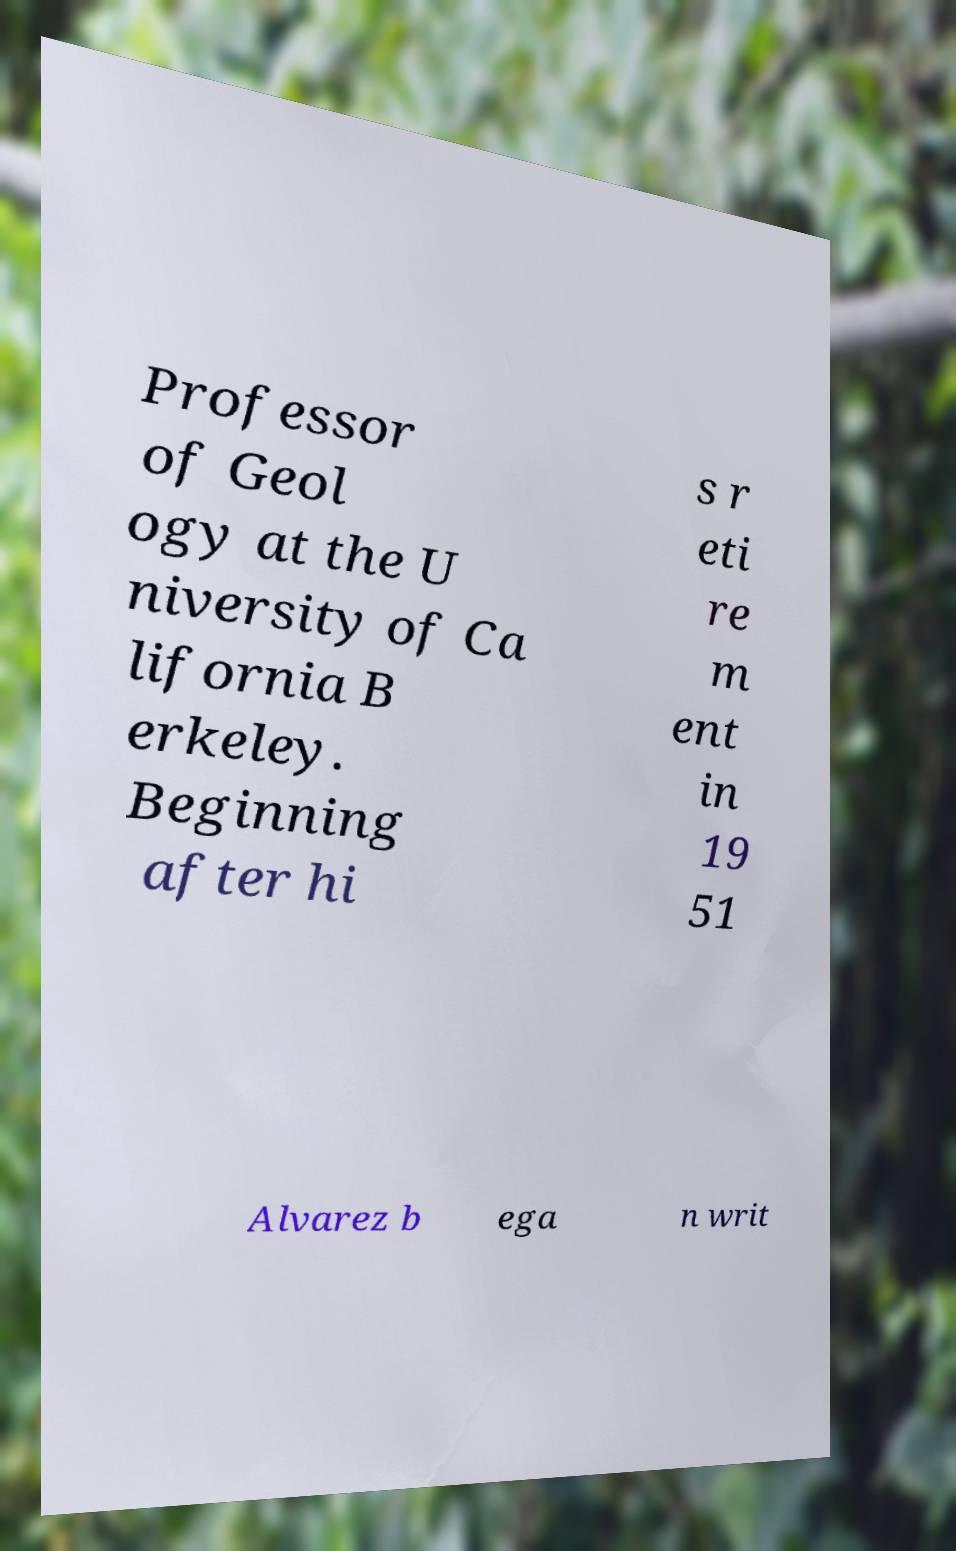Please identify and transcribe the text found in this image. Professor of Geol ogy at the U niversity of Ca lifornia B erkeley. Beginning after hi s r eti re m ent in 19 51 Alvarez b ega n writ 